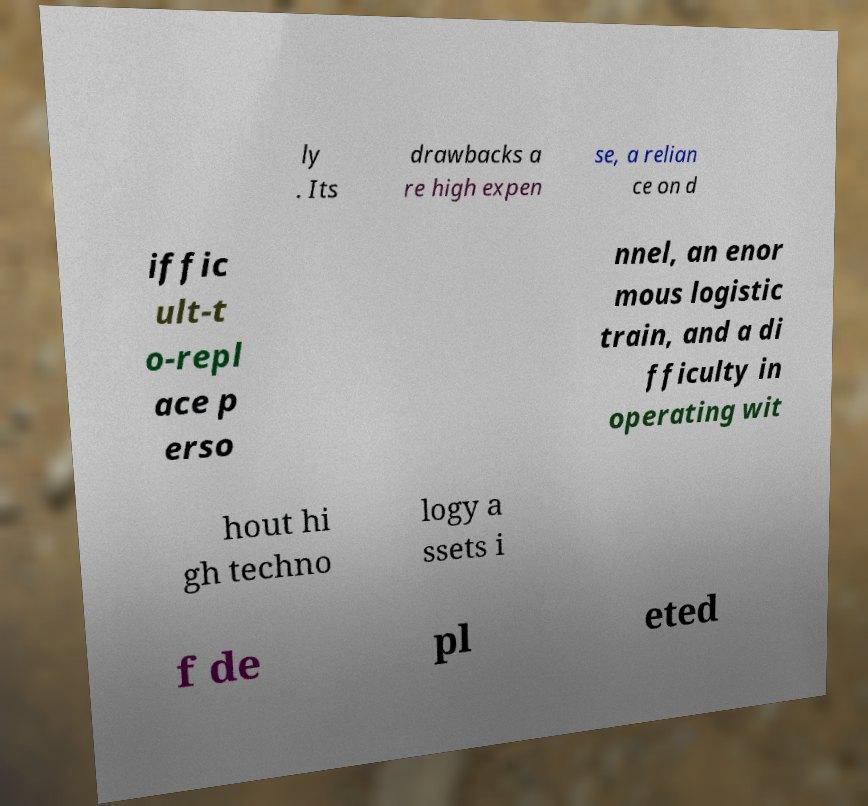What messages or text are displayed in this image? I need them in a readable, typed format. ly . Its drawbacks a re high expen se, a relian ce on d iffic ult-t o-repl ace p erso nnel, an enor mous logistic train, and a di fficulty in operating wit hout hi gh techno logy a ssets i f de pl eted 